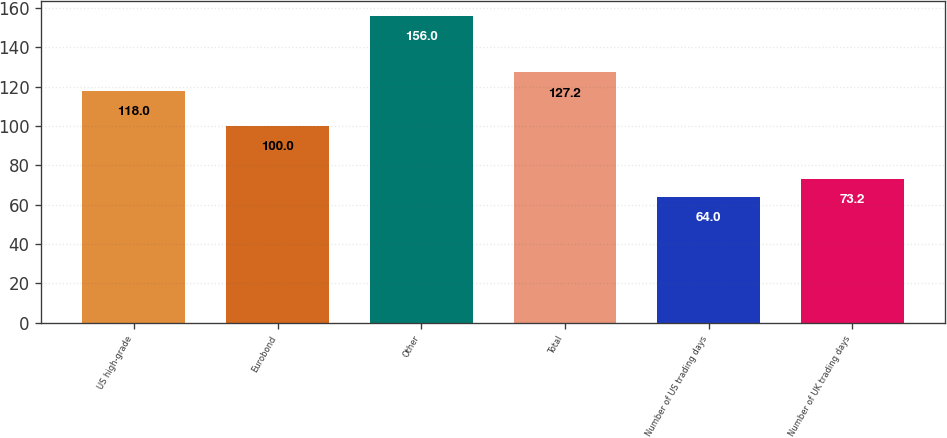<chart> <loc_0><loc_0><loc_500><loc_500><bar_chart><fcel>US high-grade<fcel>Eurobond<fcel>Other<fcel>Total<fcel>Number of US trading days<fcel>Number of UK trading days<nl><fcel>118<fcel>100<fcel>156<fcel>127.2<fcel>64<fcel>73.2<nl></chart> 